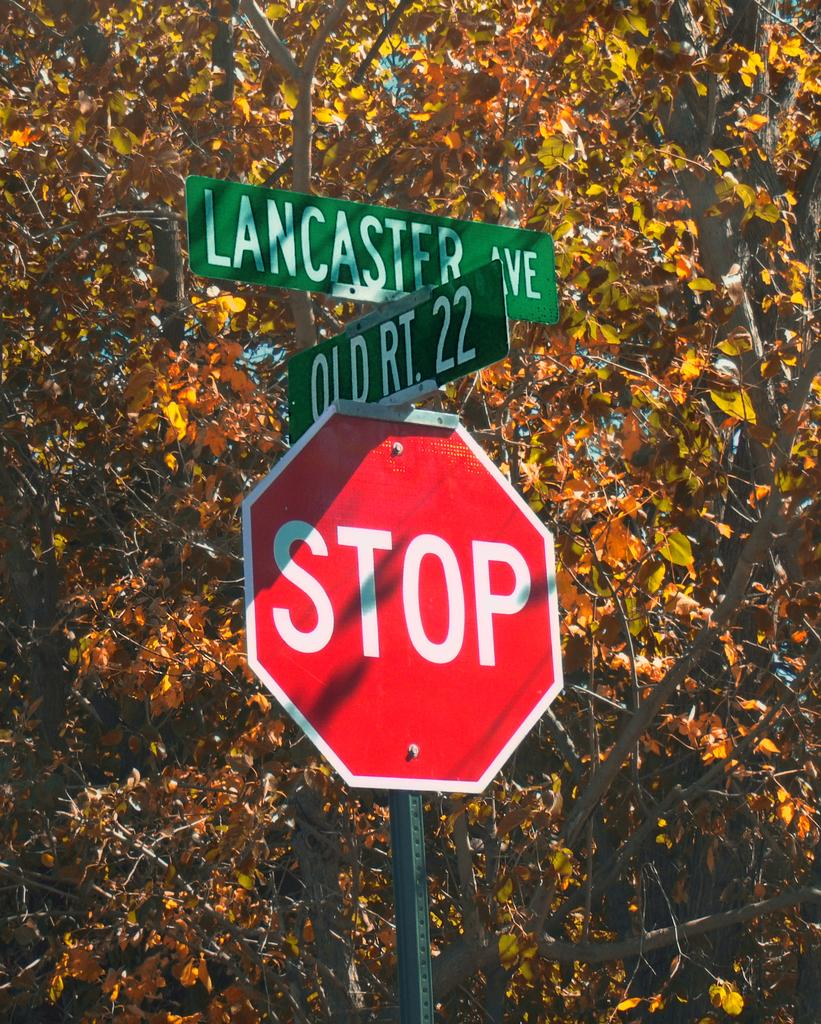<image>
Create a compact narrative representing the image presented. The street signs point to Lancaster Avenue and Old Rt 22. 